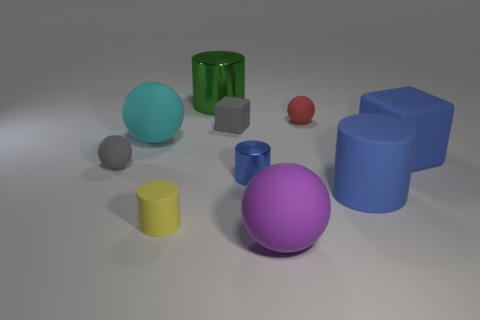Which objects in the image could fit inside the green glass cylinder if it were empty? Given the scale of objects in the image, both of the small gray cubes and the tiny red sphere could likely fit inside the green glass cylinder if it were empty. 